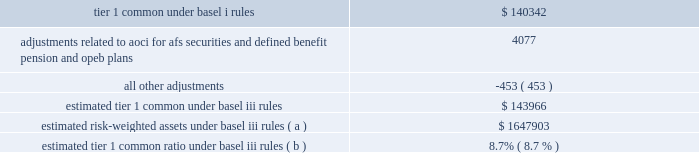Jpmorgan chase & co./2012 annual report 119 implementing further revisions to the capital accord in the u.s .
( such further revisions are commonly referred to as 201cbasel iii 201d ) .
Basel iii revised basel ii by , among other things , narrowing the definition of capital , and increasing capital requirements for specific exposures .
Basel iii also includes higher capital ratio requirements and provides that the tier 1 common capital requirement will be increased to 7% ( 7 % ) , comprised of a minimum ratio of 4.5% ( 4.5 % ) plus a 2.5% ( 2.5 % ) capital conservation buffer .
Implementation of the 7% ( 7 % ) tier 1 common capital requirement is required by january 1 , in addition , global systemically important banks ( 201cgsibs 201d ) will be required to maintain tier 1 common requirements above the 7% ( 7 % ) minimum in amounts ranging from an additional 1% ( 1 % ) to an additional 2.5% ( 2.5 % ) .
In november 2012 , the financial stability board ( 201cfsb 201d ) indicated that it would require the firm , as well as three other banks , to hold the additional 2.5% ( 2.5 % ) of tier 1 common ; the requirement will be phased in beginning in 2016 .
The basel committee also stated it intended to require certain gsibs to hold an additional 1% ( 1 % ) of tier 1 common under certain circumstances , to act as a disincentive for the gsib from taking actions that would further increase its systemic importance .
Currently , no gsib ( including the firm ) is required to hold this additional 1% ( 1 % ) of tier 1 common .
In addition , pursuant to the requirements of the dodd-frank act , u.s .
Federal banking agencies have proposed certain permanent basel i floors under basel ii and basel iii capital calculations .
The table presents a comparison of the firm 2019s tier 1 common under basel i rules to its estimated tier 1 common under basel iii rules , along with the firm 2019s estimated risk-weighted assets .
Tier 1 common under basel iii includes additional adjustments and deductions not included in basel i tier 1 common , such as the inclusion of aoci related to afs securities and defined benefit pension and other postretirement employee benefit ( 201copeb 201d ) plans .
The firm estimates that its tier 1 common ratio under basel iii rules would be 8.7% ( 8.7 % ) as of december 31 , 2012 .
The tier 1 common ratio under both basel i and basel iii are non- gaap financial measures .
However , such measures are used by bank regulators , investors and analysts as a key measure to assess the firm 2019s capital position and to compare the firm 2019s capital to that of other financial services companies .
December 31 , 2012 ( in millions , except ratios ) .
Estimated risk-weighted assets under basel iii rules ( a ) $ 1647903 estimated tier 1 common ratio under basel iii rules ( b ) 8.7% ( 8.7 % ) ( a ) key differences in the calculation of risk-weighted assets between basel i and basel iii include : ( 1 ) basel iii credit risk rwa is based on risk-sensitive approaches which largely rely on the use of internal credit models and parameters , whereas basel i rwa is based on fixed supervisory risk weightings which vary only by counterparty type and asset class ; ( 2 ) basel iii market risk rwa reflects the new capital requirements related to trading assets and securitizations , which include incremental capital requirements for stress var , correlation trading , and re-securitization positions ; and ( 3 ) basel iii includes rwa for operational risk , whereas basel i does not .
The actual impact on the firm 2019s capital ratios upon implementation could differ depending on final implementation guidance from the regulators , as well as regulatory approval of certain of the firm 2019s internal risk models .
( b ) the tier 1 common ratio is tier 1 common divided by rwa .
The firm 2019s estimate of its tier 1 common ratio under basel iii reflects its current understanding of the basel iii rules based on information currently published by the basel committee and u.s .
Federal banking agencies and on the application of such rules to its businesses as currently conducted ; it excludes the impact of any changes the firm may make in the future to its businesses as a result of implementing the basel iii rules , possible enhancements to certain market risk models , and any further implementation guidance from the regulators .
The basel iii capital requirements are subject to prolonged transition periods .
The transition period for banks to meet the tier 1 common requirement under basel iii was originally scheduled to begin in 2013 , with full implementation on january 1 , 2019 .
In november 2012 , the u.s .
Federal banking agencies announced a delay in the implementation dates for the basel iii capital requirements .
The additional capital requirements for gsibs will be phased in starting january 1 , 2016 , with full implementation on january 1 , 2019 .
Management 2019s current objective is for the firm to reach , by the end of 2013 , an estimated basel iii tier i common ratio of 9.5% ( 9.5 % ) .
Additional information regarding the firm 2019s capital ratios and the federal regulatory capital standards to which it is subject is presented in supervision and regulation on pages 1 20138 of the 2012 form 10-k , and note 28 on pages 306 2013 308 of this annual report .
Broker-dealer regulatory capital jpmorgan chase 2019s principal u.s .
Broker-dealer subsidiaries are j.p .
Morgan securities llc ( 201cjpmorgan securities 201d ) and j.p .
Morgan clearing corp .
( 201cjpmorgan clearing 201d ) .
Jpmorgan clearing is a subsidiary of jpmorgan securities and provides clearing and settlement services .
Jpmorgan securities and jpmorgan clearing are each subject to rule 15c3-1 under the securities exchange act of 1934 ( the 201cnet capital rule 201d ) .
Jpmorgan securities and jpmorgan clearing are also each registered as futures commission merchants and subject to rule 1.17 of the commodity futures trading commission ( 201ccftc 201d ) .
Jpmorgan securities and jpmorgan clearing have elected to compute their minimum net capital requirements in accordance with the 201calternative net capital requirements 201d of the net capital rule .
At december 31 , 2012 , jpmorgan securities 2019 net capital , as defined by the net capital rule , was $ 13.5 billion , exceeding the minimum requirement by .
In 2012 what was the percent of the adjustments related to aoci for afs securities and defined benefit pension and opeb plans as part of the tier 1 common under basel i rules? 
Computations: (4077 / 140342)
Answer: 0.02905. 